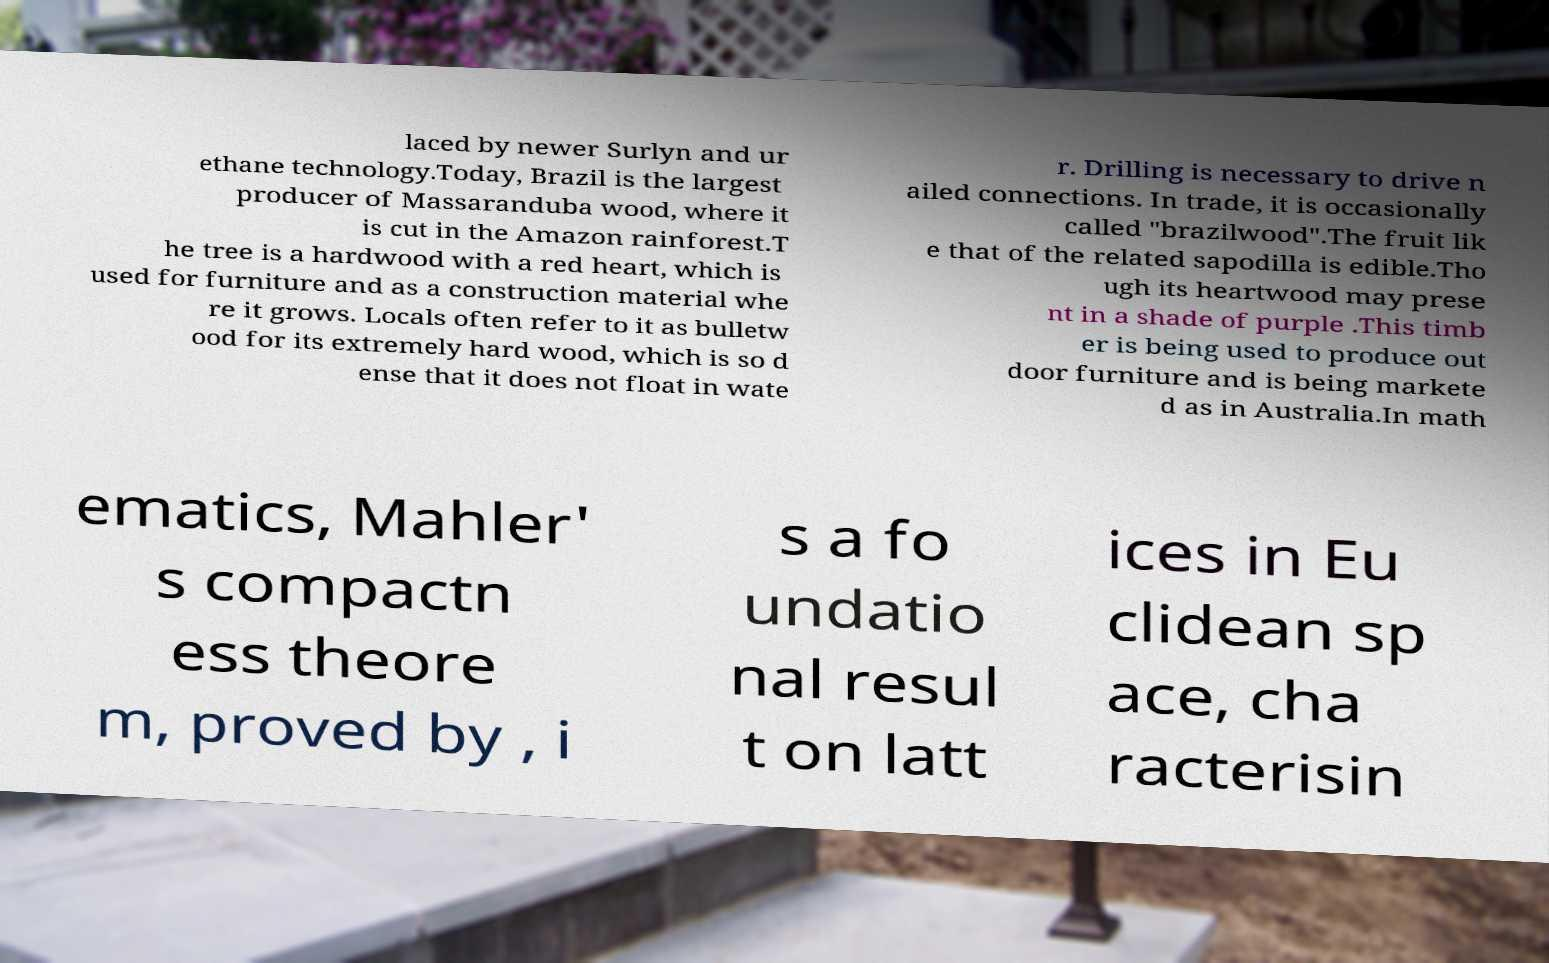Could you extract and type out the text from this image? laced by newer Surlyn and ur ethane technology.Today, Brazil is the largest producer of Massaranduba wood, where it is cut in the Amazon rainforest.T he tree is a hardwood with a red heart, which is used for furniture and as a construction material whe re it grows. Locals often refer to it as bulletw ood for its extremely hard wood, which is so d ense that it does not float in wate r. Drilling is necessary to drive n ailed connections. In trade, it is occasionally called "brazilwood".The fruit lik e that of the related sapodilla is edible.Tho ugh its heartwood may prese nt in a shade of purple .This timb er is being used to produce out door furniture and is being markete d as in Australia.In math ematics, Mahler' s compactn ess theore m, proved by , i s a fo undatio nal resul t on latt ices in Eu clidean sp ace, cha racterisin 